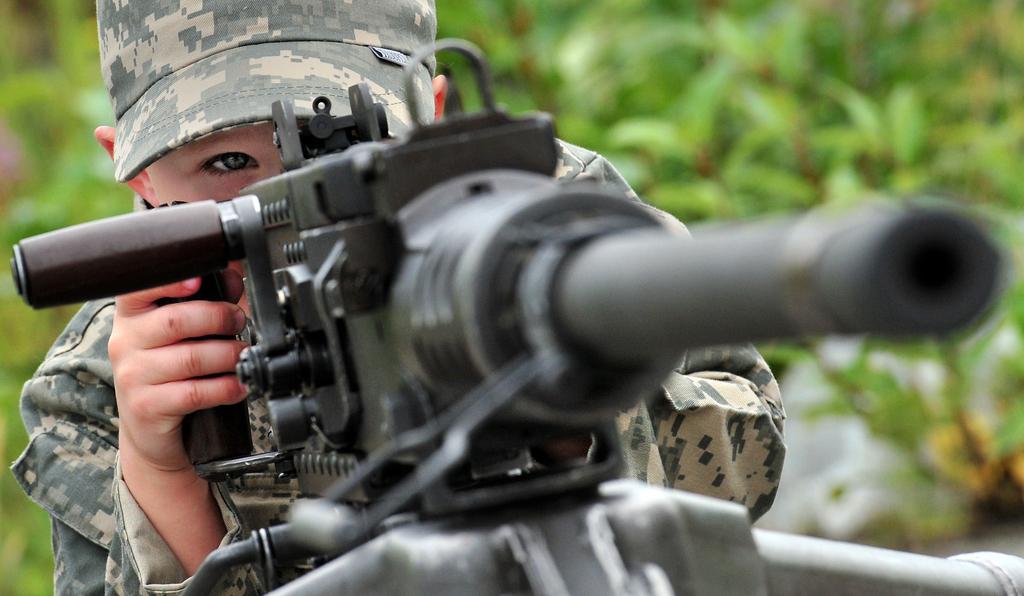Could you give a brief overview of what you see in this image? This picture shows a boy wore a cap on his head and holding a gun with his hands and we see plants. 